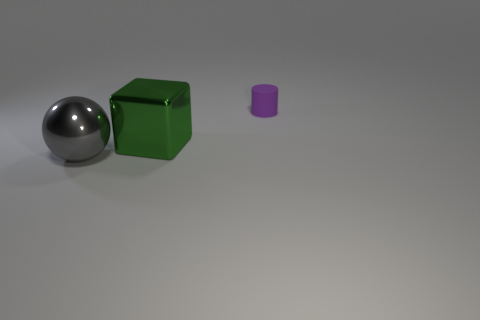Add 3 small gray rubber objects. How many objects exist? 6 Subtract 1 cubes. How many cubes are left? 0 Subtract all cylinders. How many objects are left? 2 Subtract all green cylinders. Subtract all yellow balls. How many cylinders are left? 1 Subtract all cyan blocks. How many brown cylinders are left? 0 Subtract all tiny green shiny cubes. Subtract all big things. How many objects are left? 1 Add 1 big gray objects. How many big gray objects are left? 2 Add 3 big gray metal cubes. How many big gray metal cubes exist? 3 Subtract 0 yellow cylinders. How many objects are left? 3 